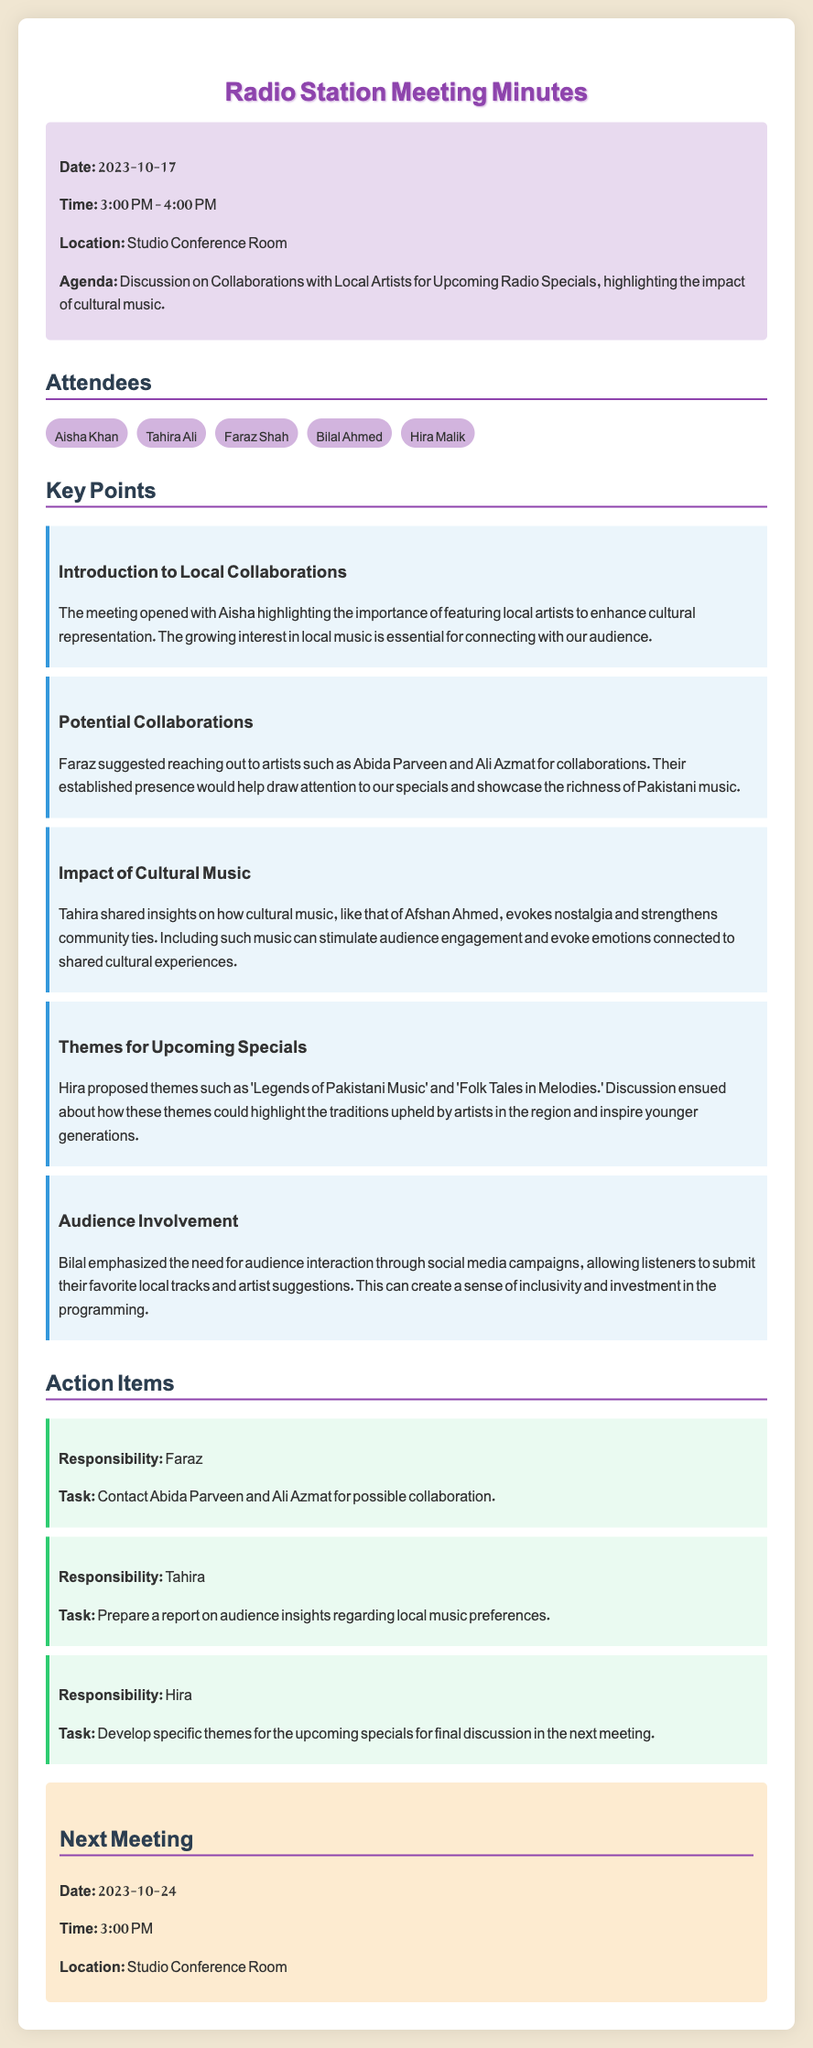what was the date of the meeting? The date of the meeting is mentioned in the info section at the top of the document.
Answer: 2023-10-17 who suggested reaching out to Abida Parveen and Ali Azmat? The meeting notes list Faraz as suggesting the outreach to these artists.
Answer: Faraz what are the proposed themes for the upcoming specials? Themes are discussed in a key point, specifically by Hira, outlining the focus for the specials.
Answer: 'Legends of Pakistani Music' and 'Folk Tales in Melodies' who is responsible for contacting artists for collaboration? The responsibility for contacting the artists is assigned to Faraz in the action items section.
Answer: Faraz how did Tahira describe the impact of cultural music? This is elaborated on in the key points section where Tahira shares insights on cultural music.
Answer: Evokes nostalgia and strengthens community ties what is the time of the next meeting? The time for the next meeting is mentioned towards the end of the document under the next meeting section.
Answer: 3:00 PM how many attendees were present at the meeting? The number of attendees can be counted from the attendees section.
Answer: 5 what action item is assigned to Tahira? Action items indicate the assigned tasks and the individual responsible for them.
Answer: Prepare a report on audience insights regarding local music preferences 